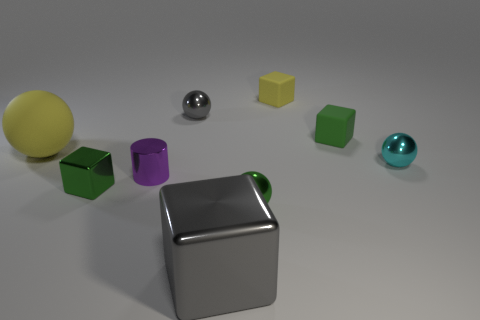There is a small sphere that is the same color as the large shiny thing; what material is it?
Your response must be concise. Metal. There is a gray metal object in front of the green shiny object that is to the left of the metal cylinder; are there any objects in front of it?
Offer a very short reply. No. Is the material of the large object that is on the right side of the purple thing the same as the green cube behind the cyan shiny ball?
Your answer should be very brief. No. What number of objects are either tiny green metallic things or green rubber blocks behind the cyan sphere?
Provide a short and direct response. 3. How many tiny green rubber objects have the same shape as the big yellow object?
Provide a succinct answer. 0. What is the material of the yellow object that is the same size as the gray shiny block?
Provide a short and direct response. Rubber. What is the size of the gray object behind the gray metal object that is in front of the metal cube on the left side of the small purple shiny object?
Keep it short and to the point. Small. Is the color of the large thing that is behind the tiny green shiny sphere the same as the tiny ball behind the matte sphere?
Provide a short and direct response. No. How many red objects are small balls or large things?
Offer a terse response. 0. What number of other objects are the same size as the green rubber thing?
Provide a succinct answer. 6. 